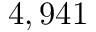Convert formula to latex. <formula><loc_0><loc_0><loc_500><loc_500>4 , 9 4 1</formula> 